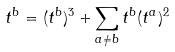Convert formula to latex. <formula><loc_0><loc_0><loc_500><loc_500>t ^ { b } = ( t ^ { b } ) ^ { 3 } + \sum _ { a \neq b } t ^ { b } ( t ^ { a } ) ^ { 2 }</formula> 